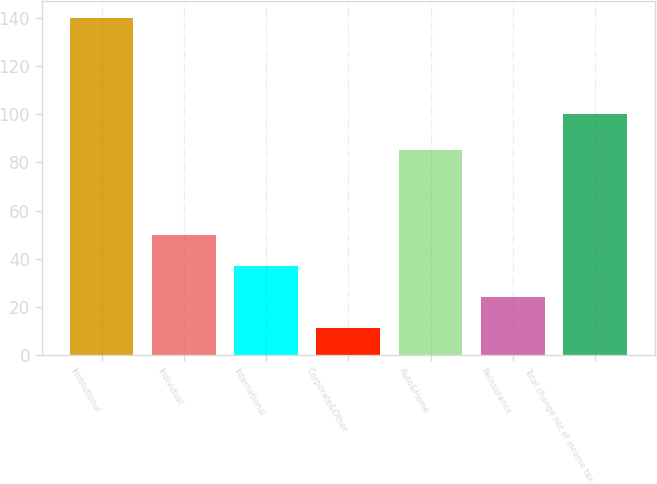Convert chart to OTSL. <chart><loc_0><loc_0><loc_500><loc_500><bar_chart><fcel>Institutional<fcel>Individual<fcel>International<fcel>Corporate&Other<fcel>Auto&Home<fcel>Reinsurance<fcel>Total change net of income tax<nl><fcel>140<fcel>49.7<fcel>36.8<fcel>11<fcel>85<fcel>23.9<fcel>100<nl></chart> 